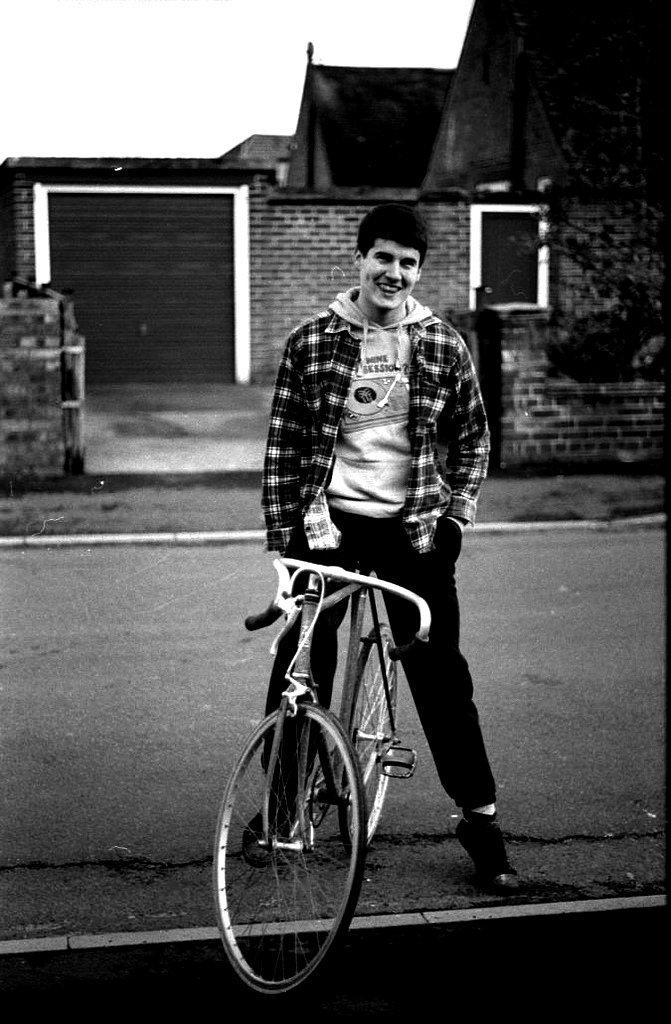Who is present in the image? There is a man in the image. What is the man doing in the image? The man is sitting on a bicycle. What is the man's facial expression in the image? The man is smiling. What can be seen in the background of the image? There is a building in the background of the image. What type of form is the man holding in the image? There is no form present in the image; the man is sitting on a bicycle and smiling. Can you see any twigs in the image? There are no twigs visible in the image. 